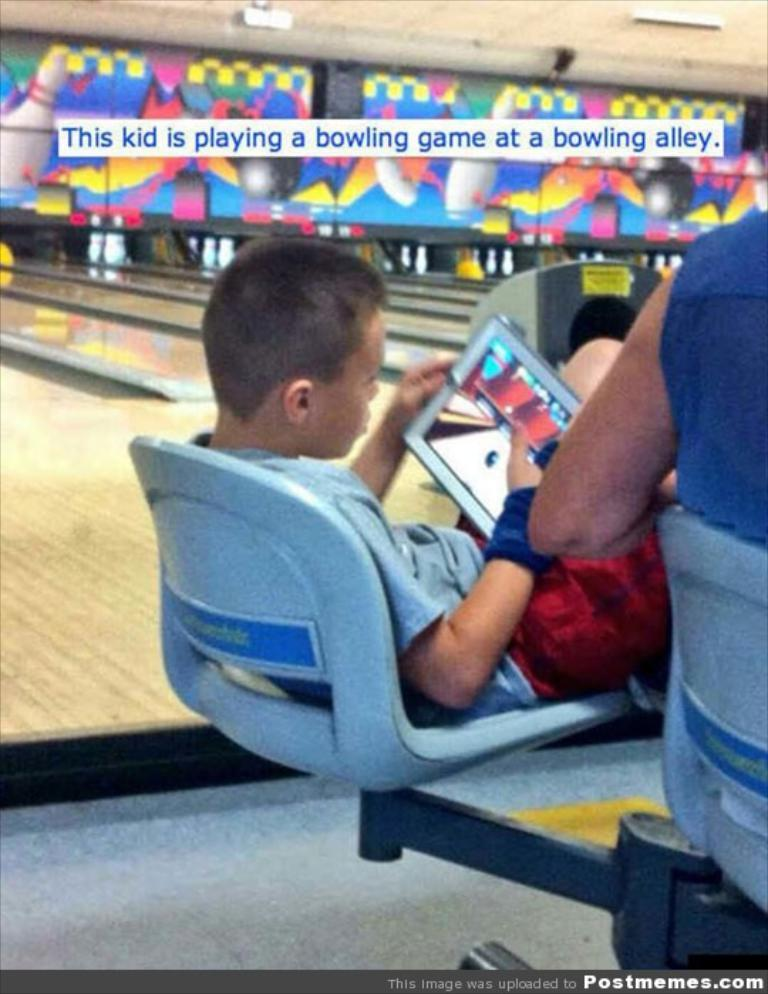<image>
Relay a brief, clear account of the picture shown. a kid playing a game on his tablet with the word bowling above him 